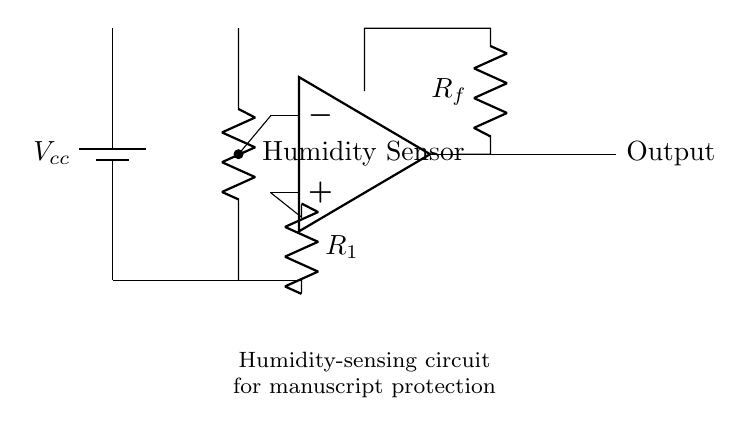What is the type of sensor used in this circuit? The circuit includes a humidity sensor, specifically labeled as "Humidity Sensor" in the diagram.
Answer: Humidity Sensor What is the purpose of the operational amplifier in this circuit? The operational amplifier amplifies the voltage signal generated by the humidity sensor, utilizing feedback from the resistor network for stability and precision.
Answer: Amplification What does the variable "Vcc" represent in this circuit? "Vcc" represents the supply voltage for the circuit, providing the necessary power for the operation of the components such as the humidity sensor and op-amp.
Answer: Supply voltage How many resistors are present in the circuit? There are two resistors, labeled as "R1" and "R_f," which are used in the circuit for different roles, contributing to the operation of the op-amp and signal processing.
Answer: Two What is the connection type between the output of the operational amplifier and the output node in the circuit? The output of the operational amplifier is connected by a direct line to the output node, indicating that the processed humidity signal is directly sent out from the op-amp.
Answer: Direct connection What is the role of the feedback resistor in this circuit? The feedback resistor, labeled as "R_f," is crucial in determining the gain of the operational amplifier, thus affecting its output response based on the input from the humidity sensor.
Answer: Gain adjustment 